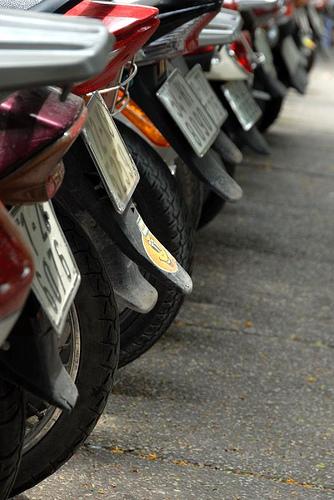Are these motorcycles outside?
Write a very short answer. Yes. What are the motorcycles sitting on?
Short answer required. Pavement. How many wheels are in the picture?
Give a very brief answer. 6. 